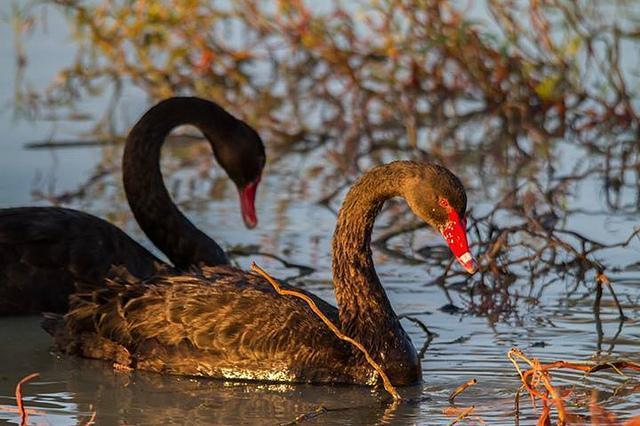How many birds are visible?
Give a very brief answer. 2. How many people can sleep in this room?
Give a very brief answer. 0. 